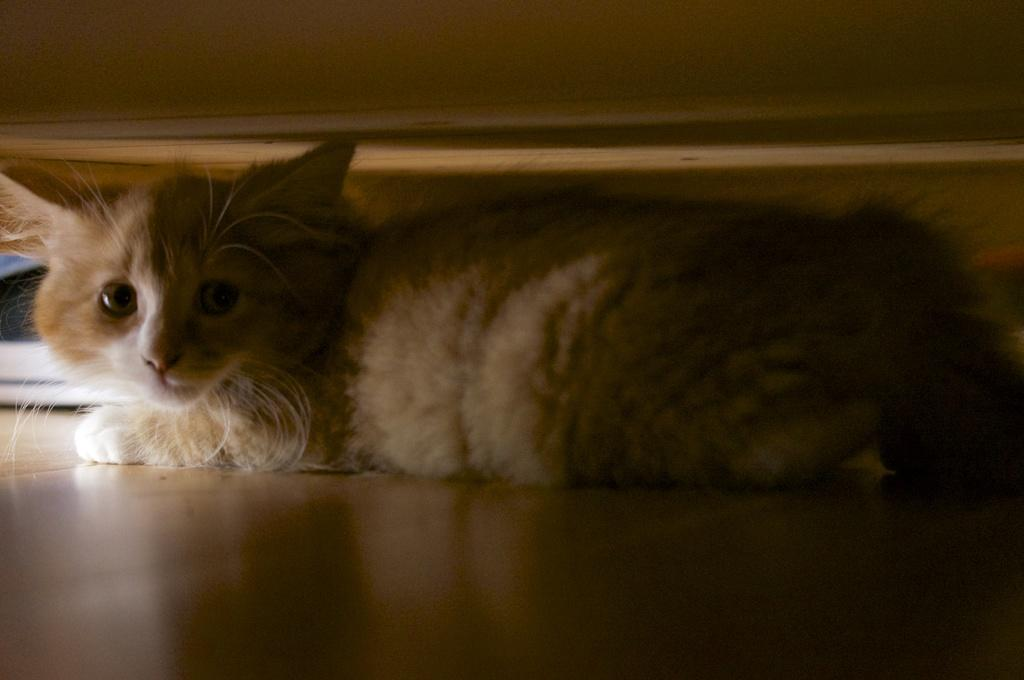What animal can be seen in the image? There is a cat laying on a surface in the image. What object is visible at the top of the image? The information provided does not specify the nature of the object at the top of the image. What color is visible on the left side of the image? There is a white color visible on the left side of the image. How many lizards are crawling on the linen in the image? There are no lizards or linen present in the image. 